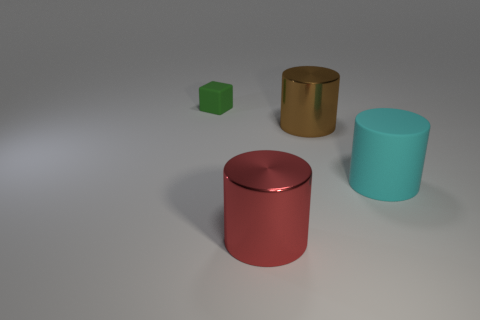Add 4 matte things. How many objects exist? 8 Subtract all blocks. How many objects are left? 3 Subtract all cyan cylinders. Subtract all large green metal spheres. How many objects are left? 3 Add 1 cyan objects. How many cyan objects are left? 2 Add 3 brown cylinders. How many brown cylinders exist? 4 Subtract 1 red cylinders. How many objects are left? 3 